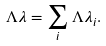<formula> <loc_0><loc_0><loc_500><loc_500>\Lambda \lambda = \sum _ { i } \Lambda \lambda _ { i } .</formula> 